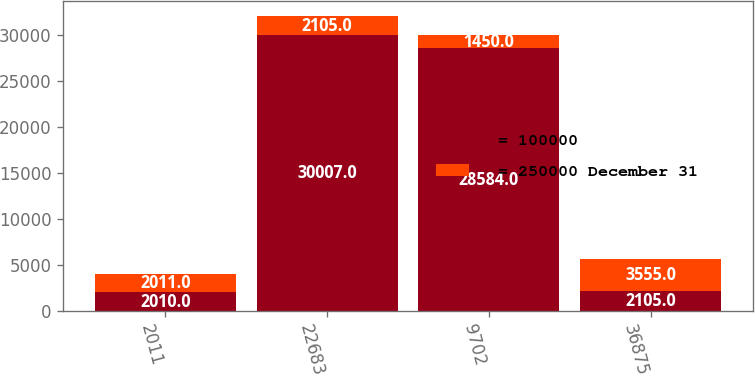Convert chart to OTSL. <chart><loc_0><loc_0><loc_500><loc_500><stacked_bar_chart><ecel><fcel>2011<fcel>22683<fcel>9702<fcel>36875<nl><fcel>= 100000<fcel>2010<fcel>30007<fcel>28584<fcel>2105<nl><fcel>= 250000 December 31<fcel>2011<fcel>2105<fcel>1450<fcel>3555<nl></chart> 